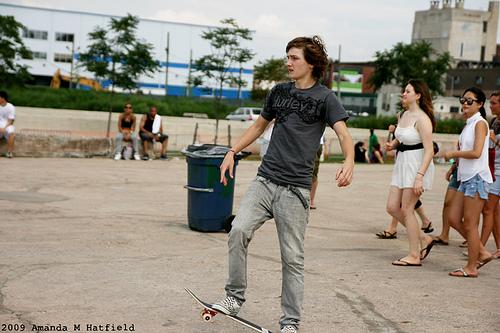Are the girls wearing pants?
Be succinct. No. Who is shirtless?
Concise answer only. No one. What are the people walking past?
Concise answer only. Trash can. Do you see a baseball cap?
Concise answer only. No. What is on the man's head?
Answer briefly. Hair. Does the weather appear warm in this photo?
Quick response, please. Yes. Is this photo taken at night?
Keep it brief. No. What is the kid doing?
Short answer required. Skateboarding. Is the man on the skateboard shirtless?
Keep it brief. No. Are these people at a beach?
Concise answer only. No. Is this a dog park?
Keep it brief. No. Where are all the people going?
Give a very brief answer. Skateboarding. Is there anyone on the skateboard?
Answer briefly. Yes. Is the skateboarder proud of his appearance?
Be succinct. Yes. 